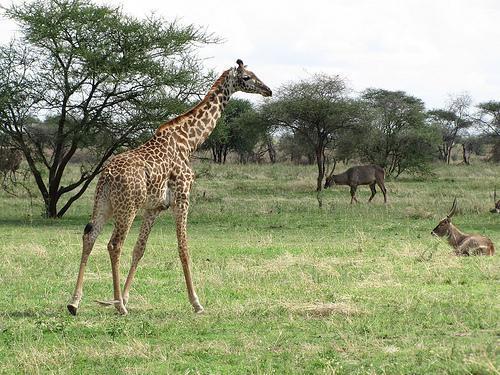How many of the animals have horns?
Give a very brief answer. 2. 